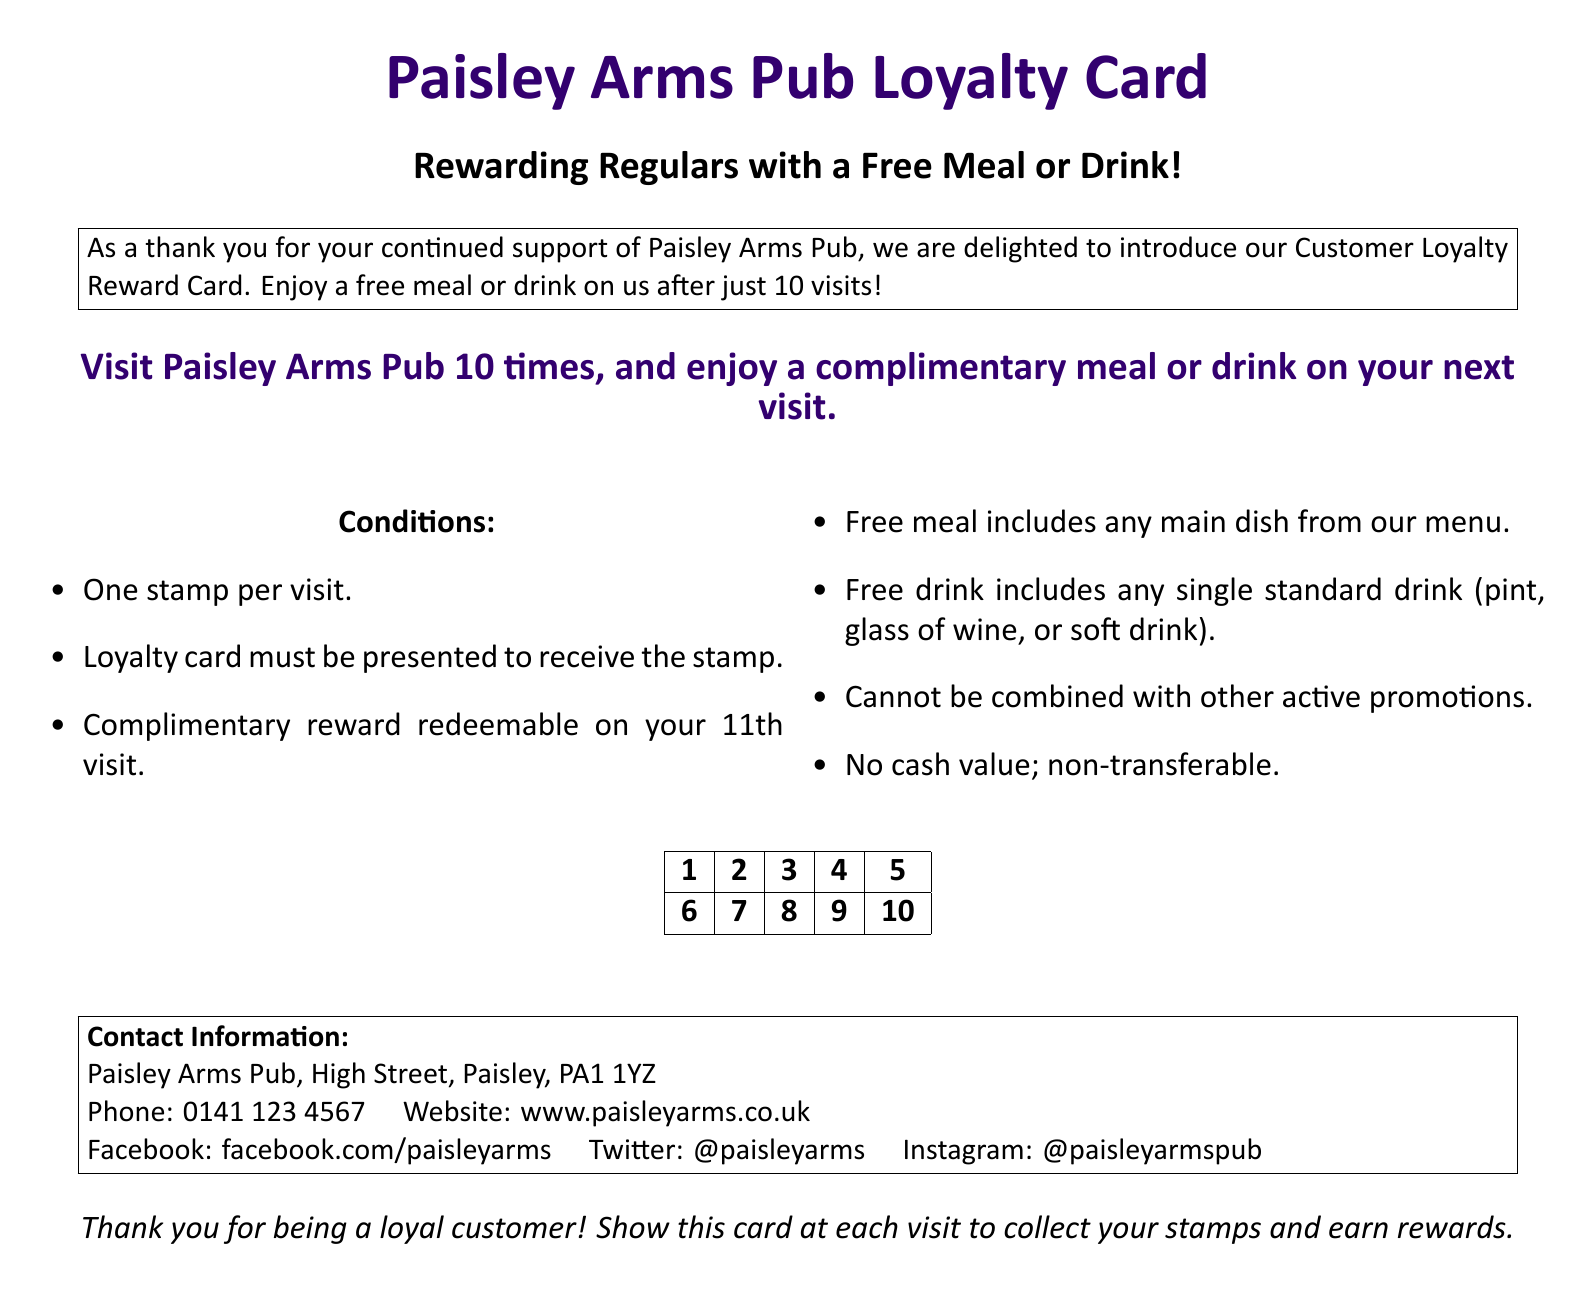What is the name of the pub? The document states the name of the pub prominently at the top.
Answer: Paisley Arms Pub How many visits are required for a complimentary meal or drink? The document specifies the number of visits needed to redeem the reward.
Answer: 10 visits What does the loyalty card offer? The document describes what customers can receive after collecting enough stamps.
Answer: A free meal or drink What is the location of Paisley Arms Pub? The contact information section of the document includes the address of the pub.
Answer: High Street, Paisley, PA1 1YZ Which social media platform is associated with the pub? The document lists several social media platforms where the pub can be followed.
Answer: Facebook How many stamps can be collected in one visit? The conditions section of the document indicates how many stamps can be earned during a visit.
Answer: One stamp Can the reward be combined with other promotions? The conditions explicitly state whether the loyalty reward can be combined with other offers.
Answer: No What type of drink is included in the free drink offer? The document mentions the types of drinks that can be redeemed with the loyalty card.
Answer: Any single standard drink What is the color scheme of the loyalty card? The document uses specific colors associated with St Mirren throughout the design.
Answer: Purple and black 